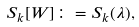<formula> <loc_0><loc_0><loc_500><loc_500>S _ { k } [ W ] \colon = S _ { k } ( \lambda ) ,</formula> 